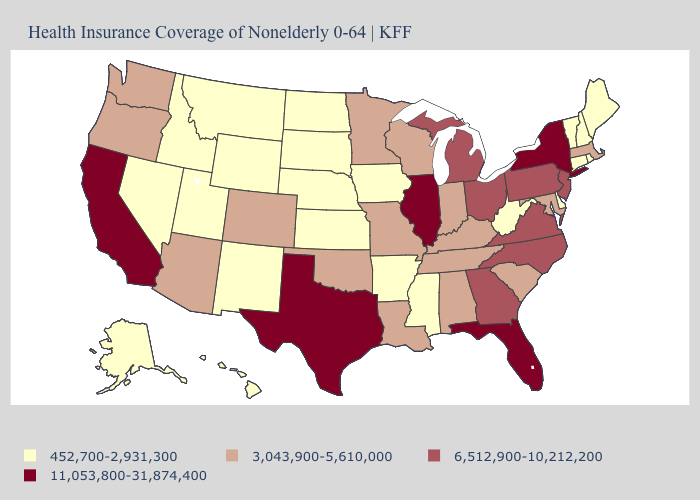Does Florida have a higher value than West Virginia?
Quick response, please. Yes. Name the states that have a value in the range 452,700-2,931,300?
Quick response, please. Alaska, Arkansas, Connecticut, Delaware, Hawaii, Idaho, Iowa, Kansas, Maine, Mississippi, Montana, Nebraska, Nevada, New Hampshire, New Mexico, North Dakota, Rhode Island, South Dakota, Utah, Vermont, West Virginia, Wyoming. Name the states that have a value in the range 452,700-2,931,300?
Keep it brief. Alaska, Arkansas, Connecticut, Delaware, Hawaii, Idaho, Iowa, Kansas, Maine, Mississippi, Montana, Nebraska, Nevada, New Hampshire, New Mexico, North Dakota, Rhode Island, South Dakota, Utah, Vermont, West Virginia, Wyoming. What is the value of Virginia?
Keep it brief. 6,512,900-10,212,200. What is the value of Maryland?
Quick response, please. 3,043,900-5,610,000. Among the states that border Wyoming , which have the lowest value?
Answer briefly. Idaho, Montana, Nebraska, South Dakota, Utah. Name the states that have a value in the range 3,043,900-5,610,000?
Answer briefly. Alabama, Arizona, Colorado, Indiana, Kentucky, Louisiana, Maryland, Massachusetts, Minnesota, Missouri, Oklahoma, Oregon, South Carolina, Tennessee, Washington, Wisconsin. How many symbols are there in the legend?
Concise answer only. 4. Among the states that border Virginia , which have the lowest value?
Write a very short answer. West Virginia. Name the states that have a value in the range 3,043,900-5,610,000?
Be succinct. Alabama, Arizona, Colorado, Indiana, Kentucky, Louisiana, Maryland, Massachusetts, Minnesota, Missouri, Oklahoma, Oregon, South Carolina, Tennessee, Washington, Wisconsin. Which states have the highest value in the USA?
Keep it brief. California, Florida, Illinois, New York, Texas. Name the states that have a value in the range 3,043,900-5,610,000?
Quick response, please. Alabama, Arizona, Colorado, Indiana, Kentucky, Louisiana, Maryland, Massachusetts, Minnesota, Missouri, Oklahoma, Oregon, South Carolina, Tennessee, Washington, Wisconsin. Name the states that have a value in the range 3,043,900-5,610,000?
Quick response, please. Alabama, Arizona, Colorado, Indiana, Kentucky, Louisiana, Maryland, Massachusetts, Minnesota, Missouri, Oklahoma, Oregon, South Carolina, Tennessee, Washington, Wisconsin. What is the value of Connecticut?
Quick response, please. 452,700-2,931,300. Among the states that border Kentucky , which have the lowest value?
Short answer required. West Virginia. 